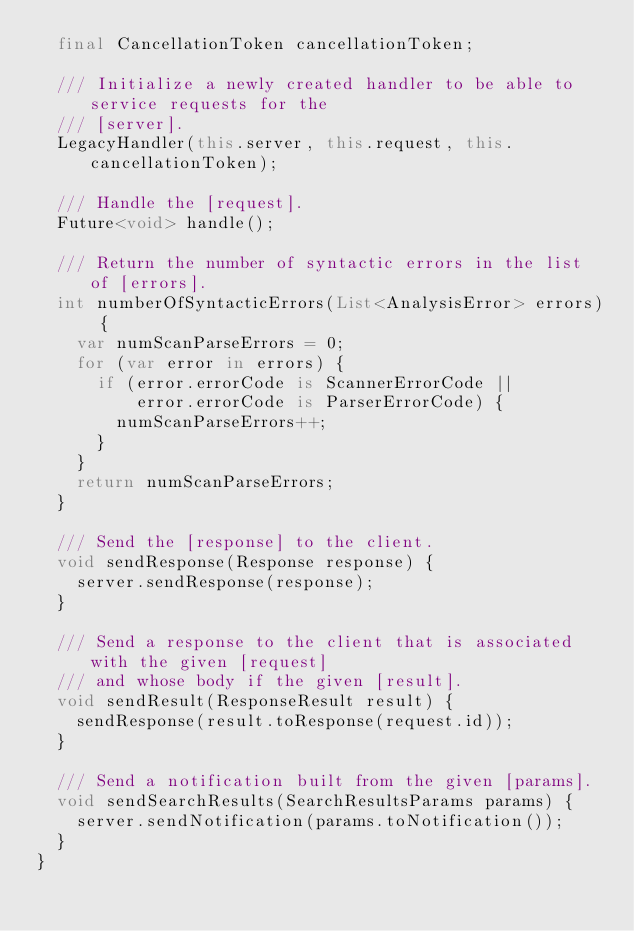Convert code to text. <code><loc_0><loc_0><loc_500><loc_500><_Dart_>  final CancellationToken cancellationToken;

  /// Initialize a newly created handler to be able to service requests for the
  /// [server].
  LegacyHandler(this.server, this.request, this.cancellationToken);

  /// Handle the [request].
  Future<void> handle();

  /// Return the number of syntactic errors in the list of [errors].
  int numberOfSyntacticErrors(List<AnalysisError> errors) {
    var numScanParseErrors = 0;
    for (var error in errors) {
      if (error.errorCode is ScannerErrorCode ||
          error.errorCode is ParserErrorCode) {
        numScanParseErrors++;
      }
    }
    return numScanParseErrors;
  }

  /// Send the [response] to the client.
  void sendResponse(Response response) {
    server.sendResponse(response);
  }

  /// Send a response to the client that is associated with the given [request]
  /// and whose body if the given [result].
  void sendResult(ResponseResult result) {
    sendResponse(result.toResponse(request.id));
  }

  /// Send a notification built from the given [params].
  void sendSearchResults(SearchResultsParams params) {
    server.sendNotification(params.toNotification());
  }
}
</code> 